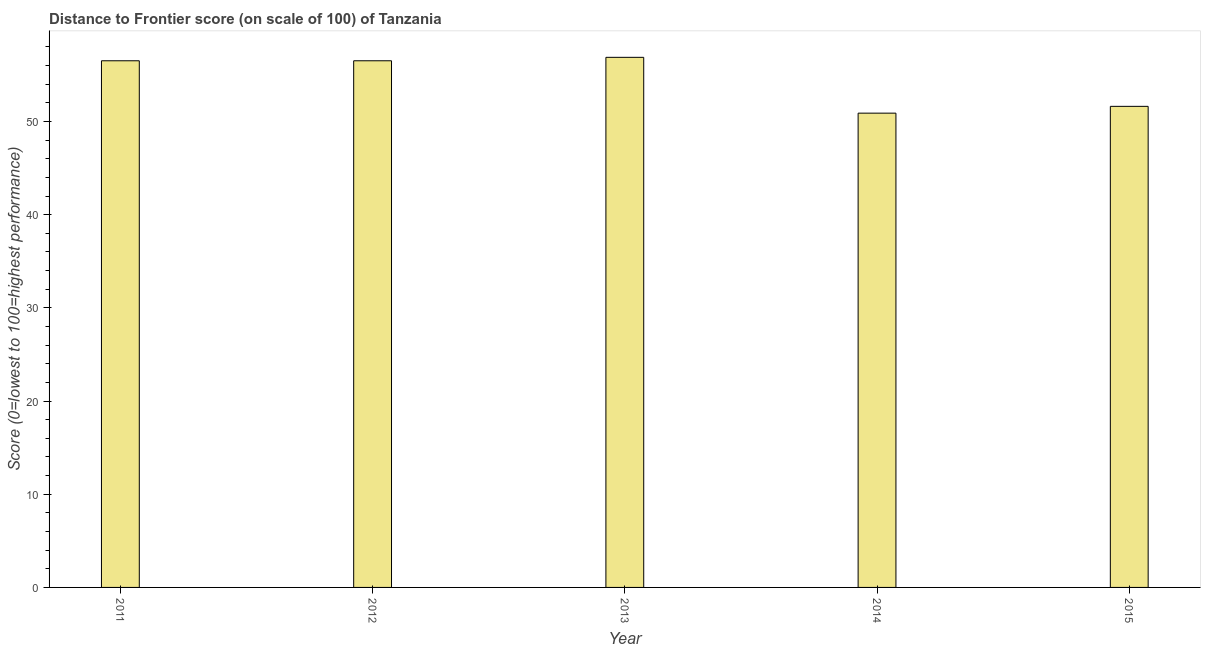Does the graph contain grids?
Keep it short and to the point. No. What is the title of the graph?
Keep it short and to the point. Distance to Frontier score (on scale of 100) of Tanzania. What is the label or title of the X-axis?
Ensure brevity in your answer.  Year. What is the label or title of the Y-axis?
Give a very brief answer. Score (0=lowest to 100=highest performance). What is the distance to frontier score in 2015?
Ensure brevity in your answer.  51.62. Across all years, what is the maximum distance to frontier score?
Provide a succinct answer. 56.88. Across all years, what is the minimum distance to frontier score?
Offer a terse response. 50.89. In which year was the distance to frontier score maximum?
Offer a terse response. 2013. What is the sum of the distance to frontier score?
Ensure brevity in your answer.  272.41. What is the average distance to frontier score per year?
Offer a terse response. 54.48. What is the median distance to frontier score?
Your answer should be very brief. 56.51. What is the ratio of the distance to frontier score in 2011 to that in 2014?
Offer a terse response. 1.11. What is the difference between the highest and the second highest distance to frontier score?
Your answer should be compact. 0.37. Is the sum of the distance to frontier score in 2011 and 2015 greater than the maximum distance to frontier score across all years?
Your answer should be compact. Yes. What is the difference between the highest and the lowest distance to frontier score?
Give a very brief answer. 5.99. What is the Score (0=lowest to 100=highest performance) in 2011?
Your answer should be compact. 56.51. What is the Score (0=lowest to 100=highest performance) of 2012?
Ensure brevity in your answer.  56.51. What is the Score (0=lowest to 100=highest performance) in 2013?
Offer a terse response. 56.88. What is the Score (0=lowest to 100=highest performance) of 2014?
Provide a succinct answer. 50.89. What is the Score (0=lowest to 100=highest performance) of 2015?
Make the answer very short. 51.62. What is the difference between the Score (0=lowest to 100=highest performance) in 2011 and 2013?
Your answer should be very brief. -0.37. What is the difference between the Score (0=lowest to 100=highest performance) in 2011 and 2014?
Ensure brevity in your answer.  5.62. What is the difference between the Score (0=lowest to 100=highest performance) in 2011 and 2015?
Offer a very short reply. 4.89. What is the difference between the Score (0=lowest to 100=highest performance) in 2012 and 2013?
Offer a terse response. -0.37. What is the difference between the Score (0=lowest to 100=highest performance) in 2012 and 2014?
Offer a very short reply. 5.62. What is the difference between the Score (0=lowest to 100=highest performance) in 2012 and 2015?
Keep it short and to the point. 4.89. What is the difference between the Score (0=lowest to 100=highest performance) in 2013 and 2014?
Keep it short and to the point. 5.99. What is the difference between the Score (0=lowest to 100=highest performance) in 2013 and 2015?
Offer a terse response. 5.26. What is the difference between the Score (0=lowest to 100=highest performance) in 2014 and 2015?
Your answer should be compact. -0.73. What is the ratio of the Score (0=lowest to 100=highest performance) in 2011 to that in 2013?
Provide a succinct answer. 0.99. What is the ratio of the Score (0=lowest to 100=highest performance) in 2011 to that in 2014?
Your answer should be compact. 1.11. What is the ratio of the Score (0=lowest to 100=highest performance) in 2011 to that in 2015?
Your answer should be very brief. 1.09. What is the ratio of the Score (0=lowest to 100=highest performance) in 2012 to that in 2013?
Your answer should be very brief. 0.99. What is the ratio of the Score (0=lowest to 100=highest performance) in 2012 to that in 2014?
Your answer should be compact. 1.11. What is the ratio of the Score (0=lowest to 100=highest performance) in 2012 to that in 2015?
Provide a short and direct response. 1.09. What is the ratio of the Score (0=lowest to 100=highest performance) in 2013 to that in 2014?
Your answer should be compact. 1.12. What is the ratio of the Score (0=lowest to 100=highest performance) in 2013 to that in 2015?
Ensure brevity in your answer.  1.1. 